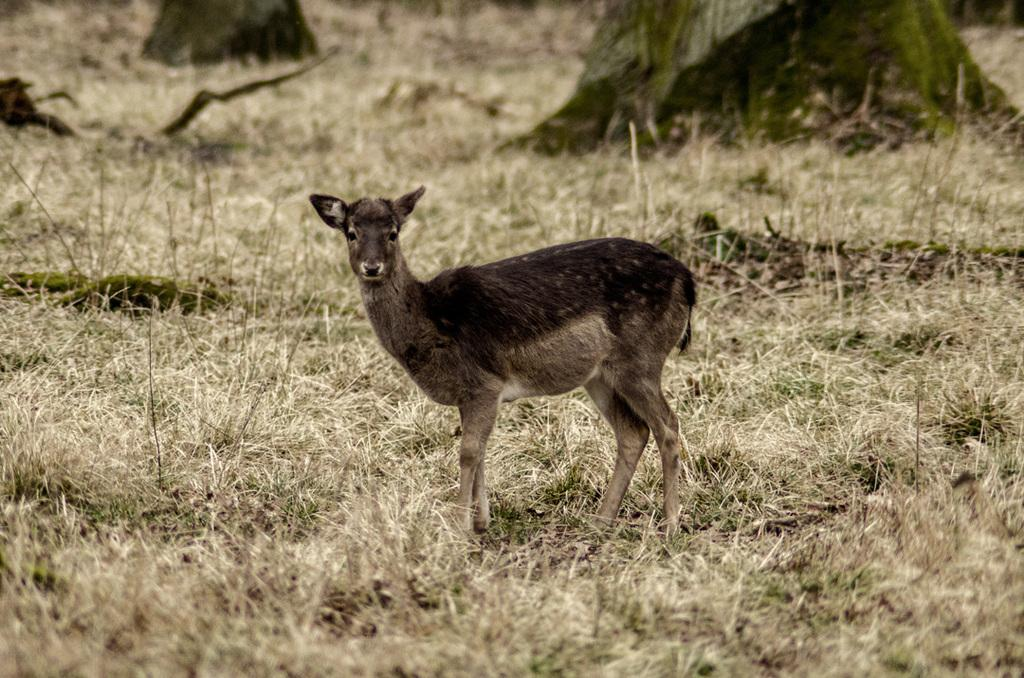What type of animal can be seen in the image? There is an animal in the image, but its specific type cannot be determined from the provided facts. What colors are present on the animal in the image? The animal is black and cream in color. Where is the animal located in the image? The animal is on the ground in the image. What type of vegetation is present on the ground in the image? There is grass on the ground in the image. What can be seen in the background of the image? There are trees in the background of the image. What type of clouds can be seen in the image? There is no mention of clouds in the provided facts, so it cannot be determined if any are present in the image. 